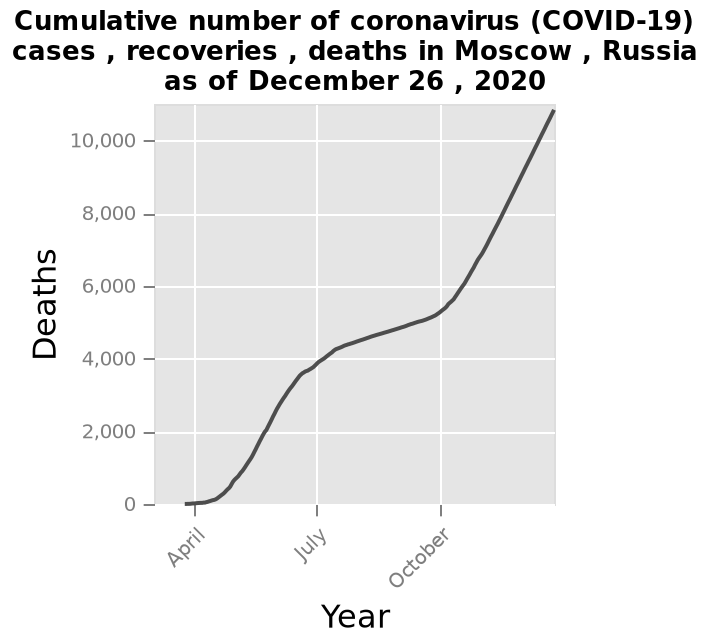<image>
What is the maximum value of the y-axis on the line plot? The maximum value of the y-axis on the line plot is 10,000. What does the y-axis of the line plot represent? The y-axis of the line plot represents Deaths. please summary the statistics and relations of the chart it is difficult to read the graph if it contains cases and recoveries. it appears to show that deaths steadied in the summer then increased massively before and after suggesting two clear surges. What does the x-axis of the line plot represent? The x-axis of the line plot represents Year. Describe the following image in detail Here a line plot is called Cumulative number of coronavirus (COVID-19) cases , recoveries , deaths in Moscow , Russia as of December 26 , 2020. The y-axis plots Deaths as a linear scale from 0 to 10,000. The x-axis plots Year. 